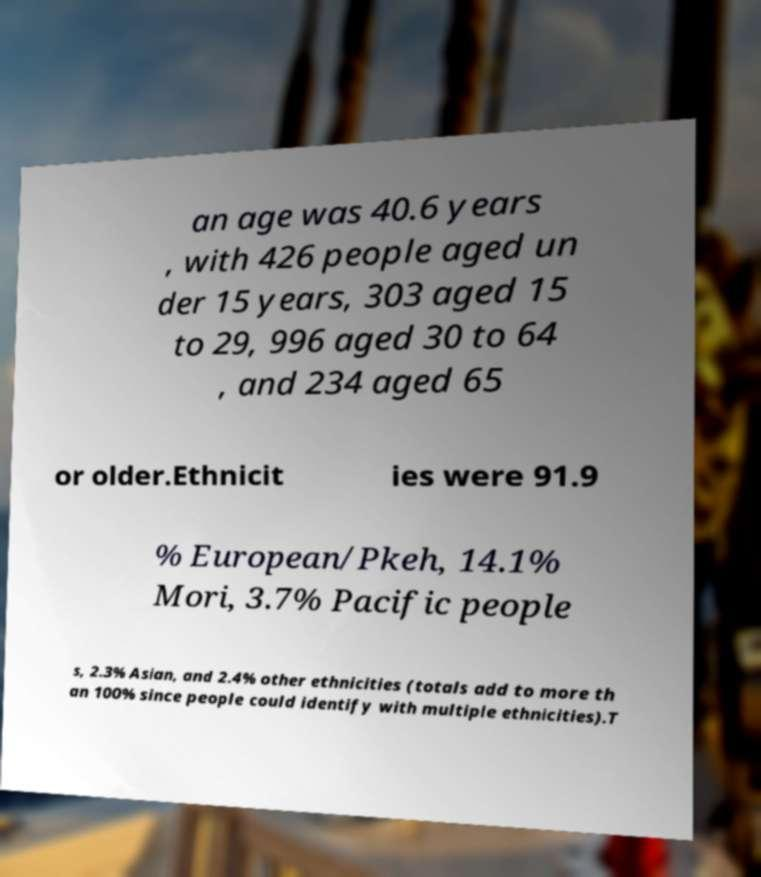Please read and relay the text visible in this image. What does it say? an age was 40.6 years , with 426 people aged un der 15 years, 303 aged 15 to 29, 996 aged 30 to 64 , and 234 aged 65 or older.Ethnicit ies were 91.9 % European/Pkeh, 14.1% Mori, 3.7% Pacific people s, 2.3% Asian, and 2.4% other ethnicities (totals add to more th an 100% since people could identify with multiple ethnicities).T 